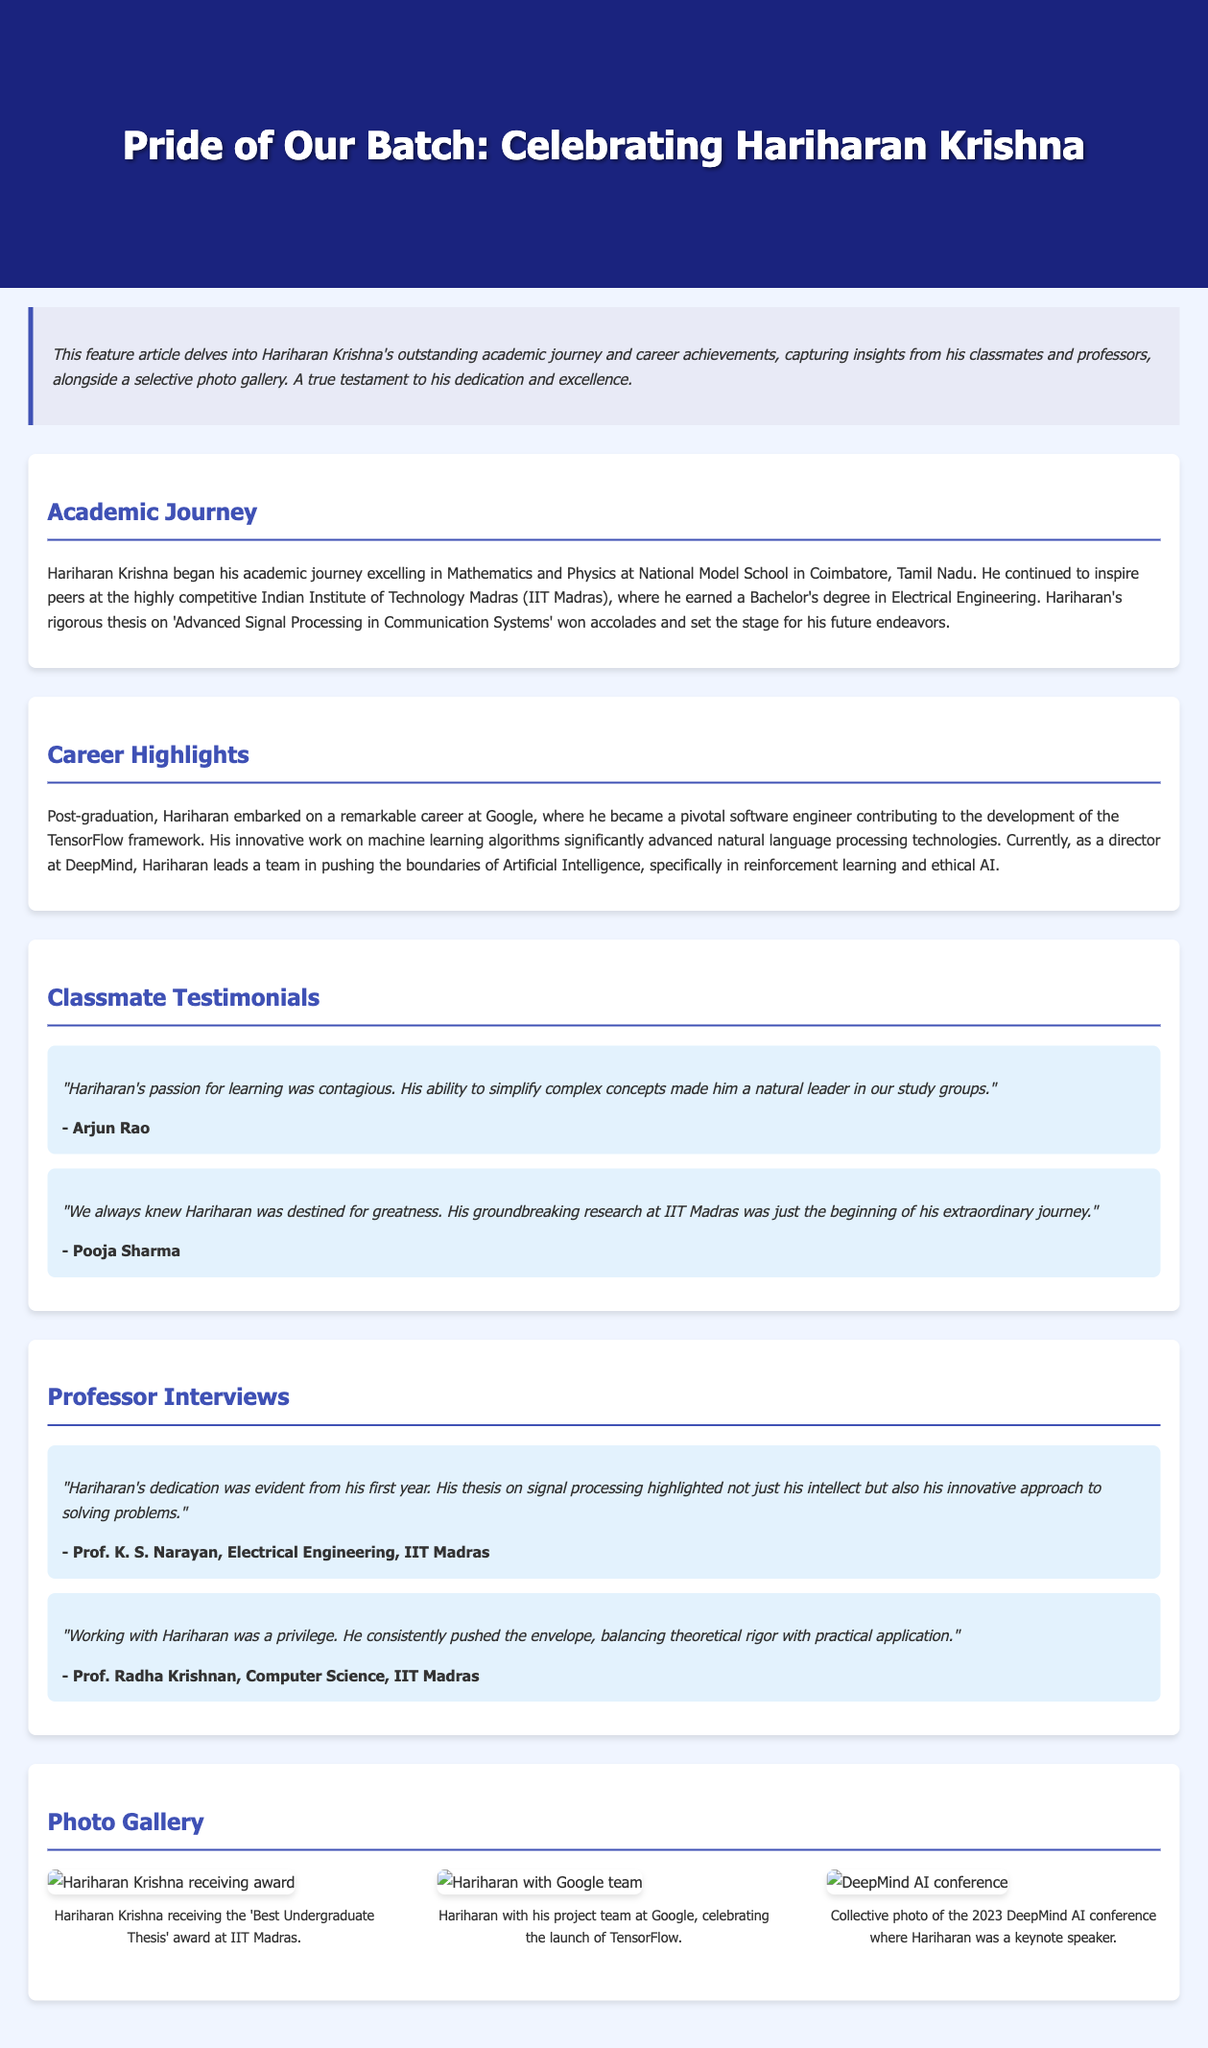What award did Hariharan receive? The document mentions that he received the 'Best Undergraduate Thesis' award at IIT Madras.
Answer: Best Undergraduate Thesis Which university did Hariharan attend for his Bachelor's degree? The document states that Hariharan earned his Bachelor's degree from the Indian Institute of Technology Madras (IIT Madras).
Answer: Indian Institute of Technology Madras What position does Hariharan currently hold? According to the document, he is currently a director at DeepMind.
Answer: Director Who said, "Working with Hariharan was a privilege"? This quote is attributed to Prof. Radha Krishnan, Computer Science, IIT Madras.
Answer: Prof. Radha Krishnan What was the focus of Hariharan's thesis? The document describes his thesis as focusing on 'Advanced Signal Processing in Communication Systems.'
Answer: Advanced Signal Processing in Communication Systems How many testimonials are included in the document? The document includes two testimonials from classmates of Hariharan.
Answer: Two What technology did Hariharan contribute to at Google? According to the document, he contributed to the development of the TensorFlow framework.
Answer: TensorFlow What was the theme of the 2023 DeepMind AI conference? The document does not specify the theme, but it mentions that Hariharan was a keynote speaker there.
Answer: Not specified What kind of approach did Hariharan take in his thesis, according to Prof. K. S. Narayan? Prof. K. S. Narayan highlighted that his thesis showed an innovative approach to solving problems.
Answer: Innovative approach 